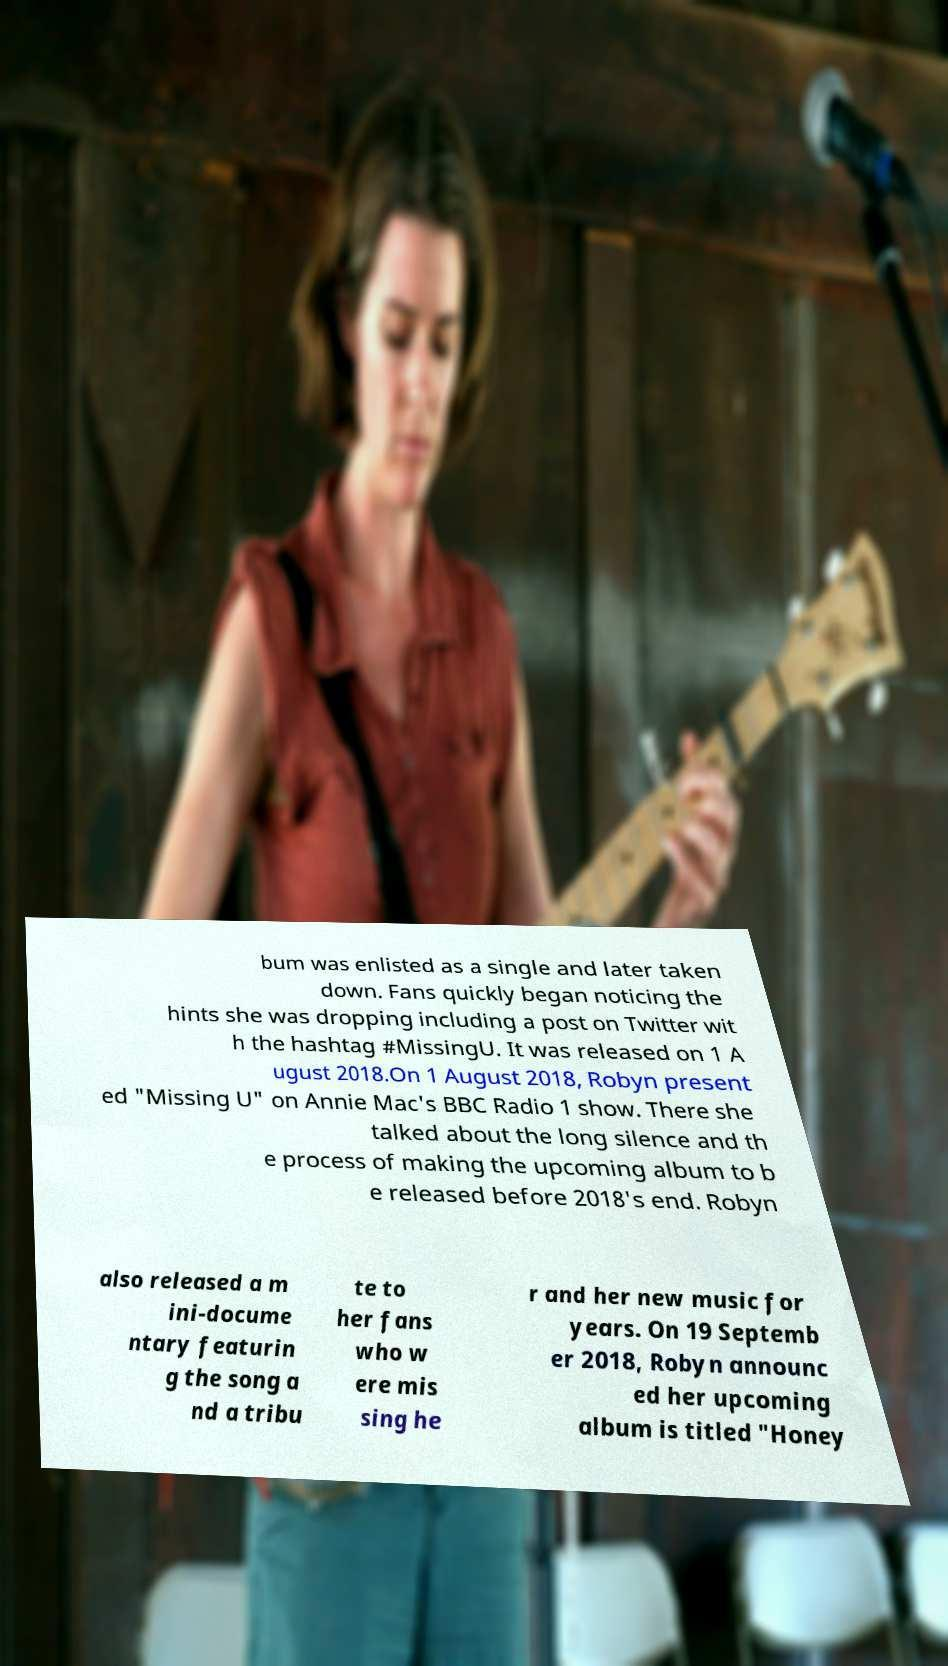Could you assist in decoding the text presented in this image and type it out clearly? bum was enlisted as a single and later taken down. Fans quickly began noticing the hints she was dropping including a post on Twitter wit h the hashtag #MissingU. It was released on 1 A ugust 2018.On 1 August 2018, Robyn present ed "Missing U" on Annie Mac's BBC Radio 1 show. There she talked about the long silence and th e process of making the upcoming album to b e released before 2018's end. Robyn also released a m ini-docume ntary featurin g the song a nd a tribu te to her fans who w ere mis sing he r and her new music for years. On 19 Septemb er 2018, Robyn announc ed her upcoming album is titled "Honey 